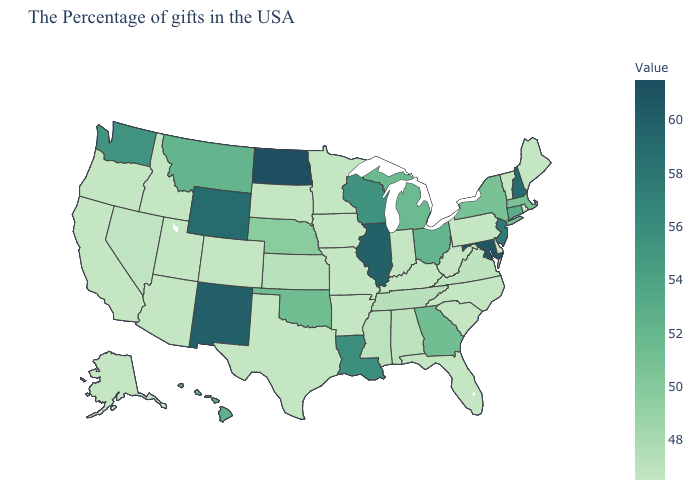Among the states that border Indiana , which have the lowest value?
Answer briefly. Kentucky. Does Wisconsin have the highest value in the MidWest?
Be succinct. No. Which states hav the highest value in the Northeast?
Answer briefly. New Hampshire. Which states have the highest value in the USA?
Concise answer only. North Dakota. Which states have the lowest value in the Northeast?
Concise answer only. Maine, Rhode Island, Vermont, Pennsylvania. 